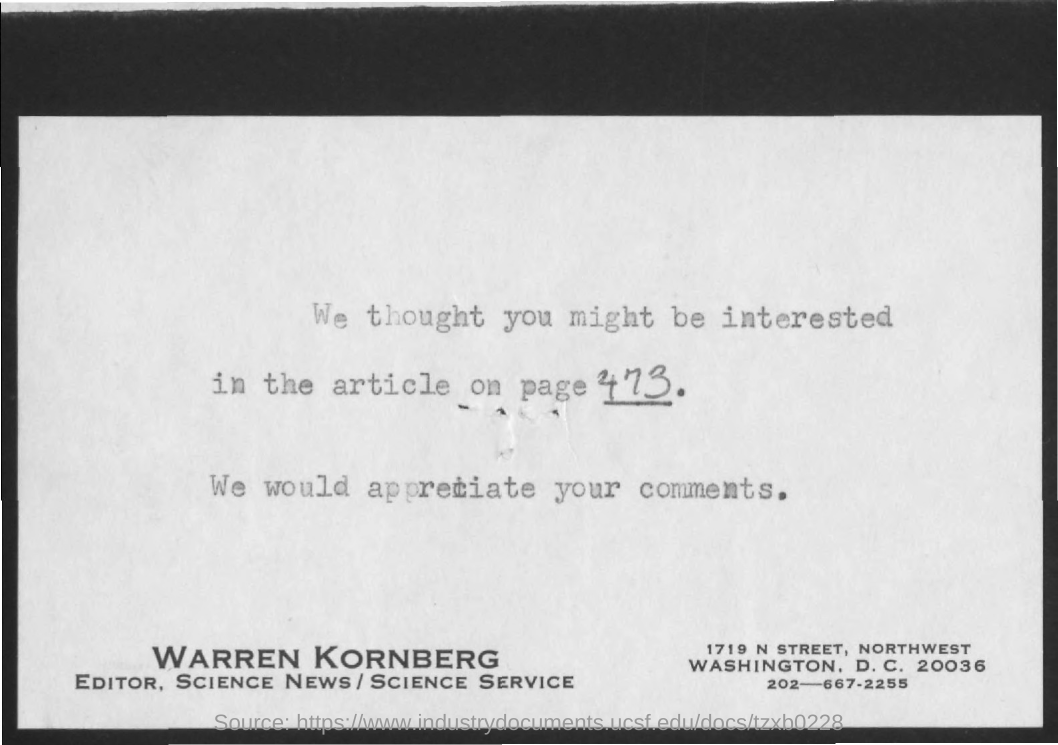What is the page no. mentioned for the article ?
Keep it short and to the point. 473. What is the name of the editor mentioned ?
Keep it short and to the point. Warren kornberg. 